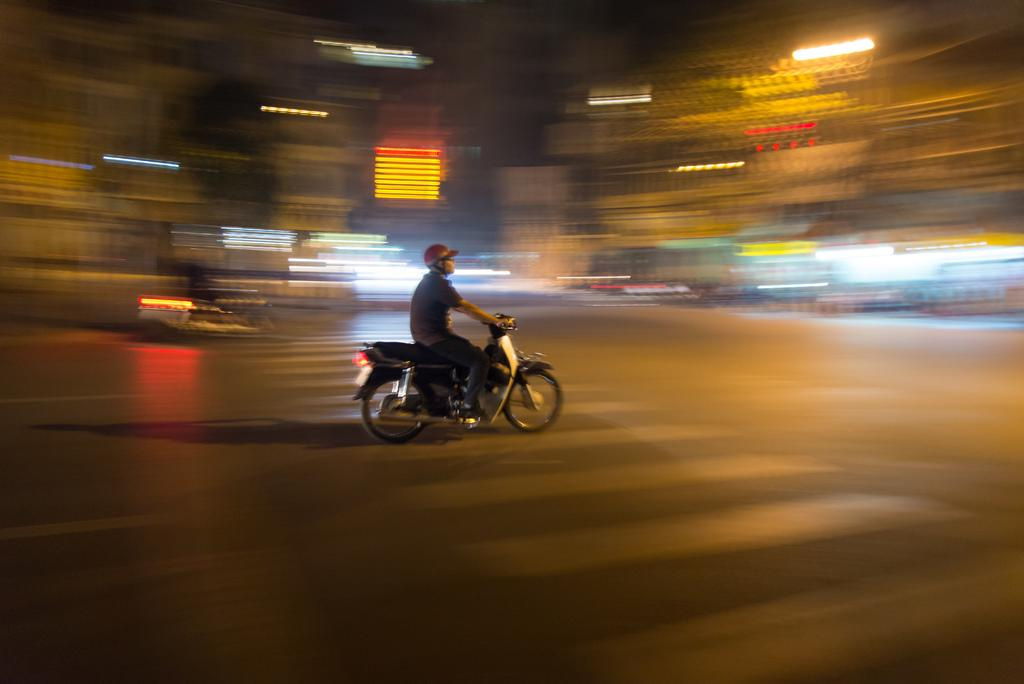What is the person in the image doing? There is a person riding a bike in the image. What safety precaution is the person taking while riding the bike? The person is wearing a helmet. What type of pedestrian crossing is visible in the image? There is a zebra crossing in the image. What type of pathway is visible in the image? There is a road visible in the image. What type of illumination is present in the image? There are lights present in the image. What type of music is the monkey playing on the road in the image? There is no monkey or music present in the image. 